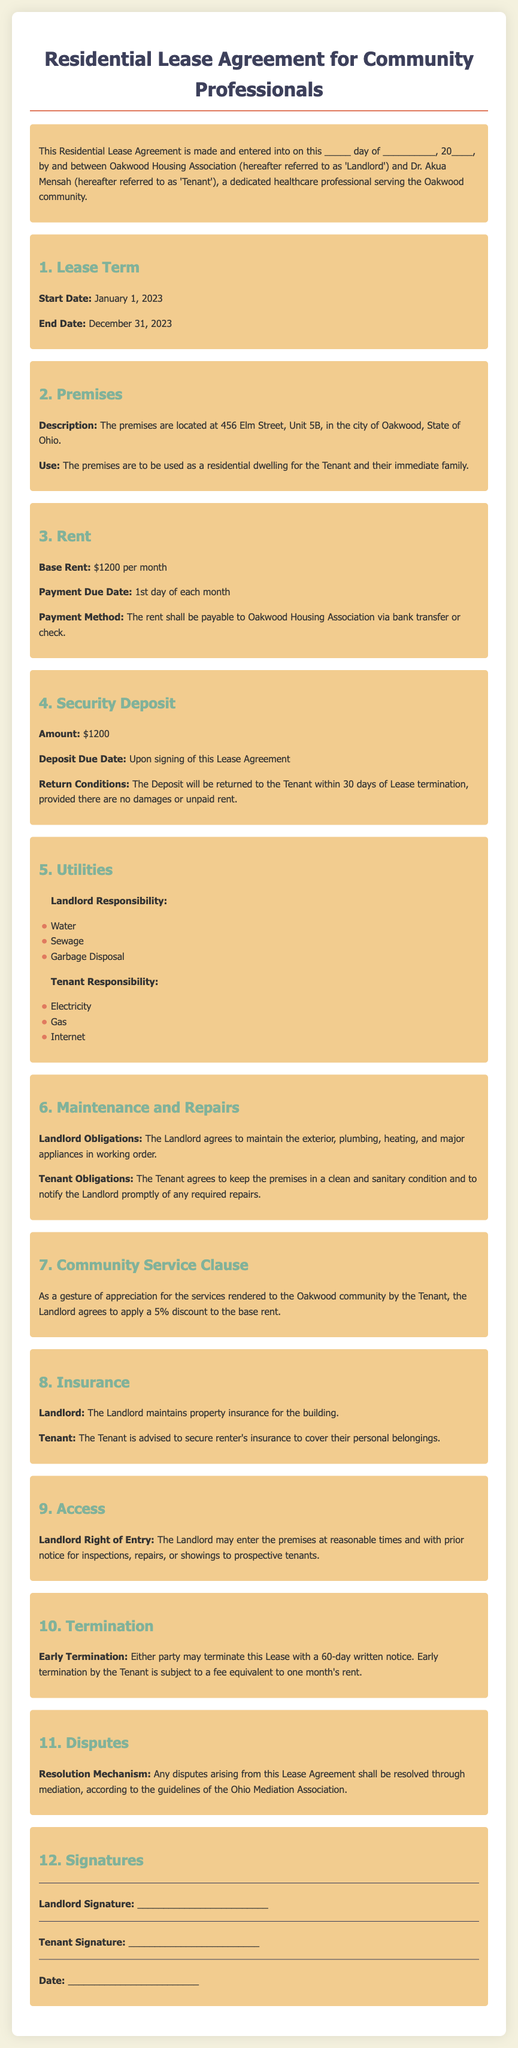What is the name of the Tenant? The Tenant's name is mentioned as Dr. Akua Mensah in the agreement.
Answer: Dr. Akua Mensah What is the base rent amount? The document states that the base rent is $1200 per month.
Answer: $1200 per month What is the security deposit amount? The amount specified for the security deposit in the agreement is also $1200.
Answer: $1200 What is the lease termination notice period? The lease agreement specifies a 60-day written notice period for termination.
Answer: 60 days What discount does the Tenant receive for community service? A 5% discount on the base rent is mentioned as a benefit for the Tenant's community service.
Answer: 5% What utilities are the Landlord responsible for? The document lists water, sewage, and garbage disposal as utilities covered by the Landlord.
Answer: Water, Sewage, Garbage Disposal How are disputes to be resolved according to the agreement? The resolution mechanism mentioned in the document is mediation through the Ohio Mediation Association.
Answer: Mediation What is the start date of the lease? The start date of the lease is explicitly given in the agreement as January 1, 2023.
Answer: January 1, 2023 What obligations does the Tenant have regarding the premises? The Tenant is obligated to keep the premises in a clean and sanitary condition and report required repairs to the Landlord.
Answer: Clean and sanitary condition 